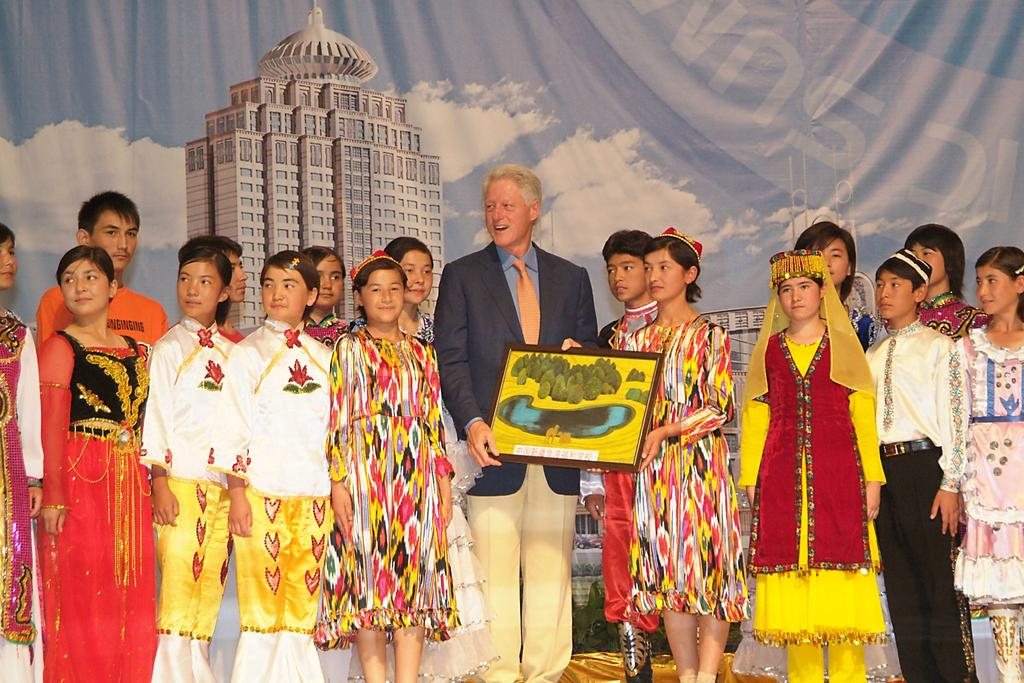How many people are in the image? There is a group of persons in the image. Where are the persons located in the image? The group of persons is standing in the middle of the image. What can be seen in the background of the image? There is a painted curtain in the background of the image. What is the person in the middle of the group holding? The person standing in the middle of the group is holding a frame. What type of iron is visible in the image? There is no iron present in the image. What caption is written on the frame being held by the person in the middle of the group? The image does not show any text or caption on the frame being held by the person in the middle of the group. 